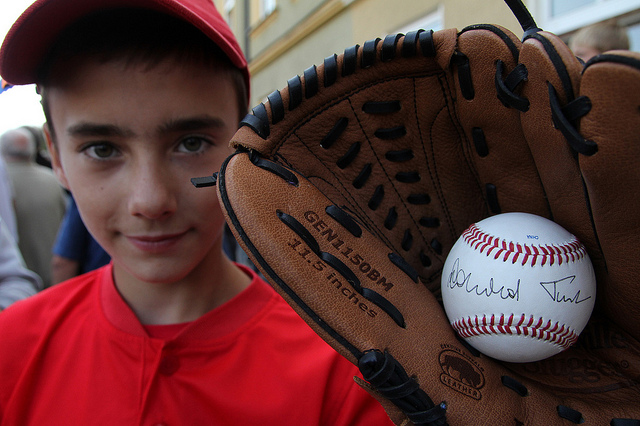Read all the text in this image. GEN1150BM .11.5 could 